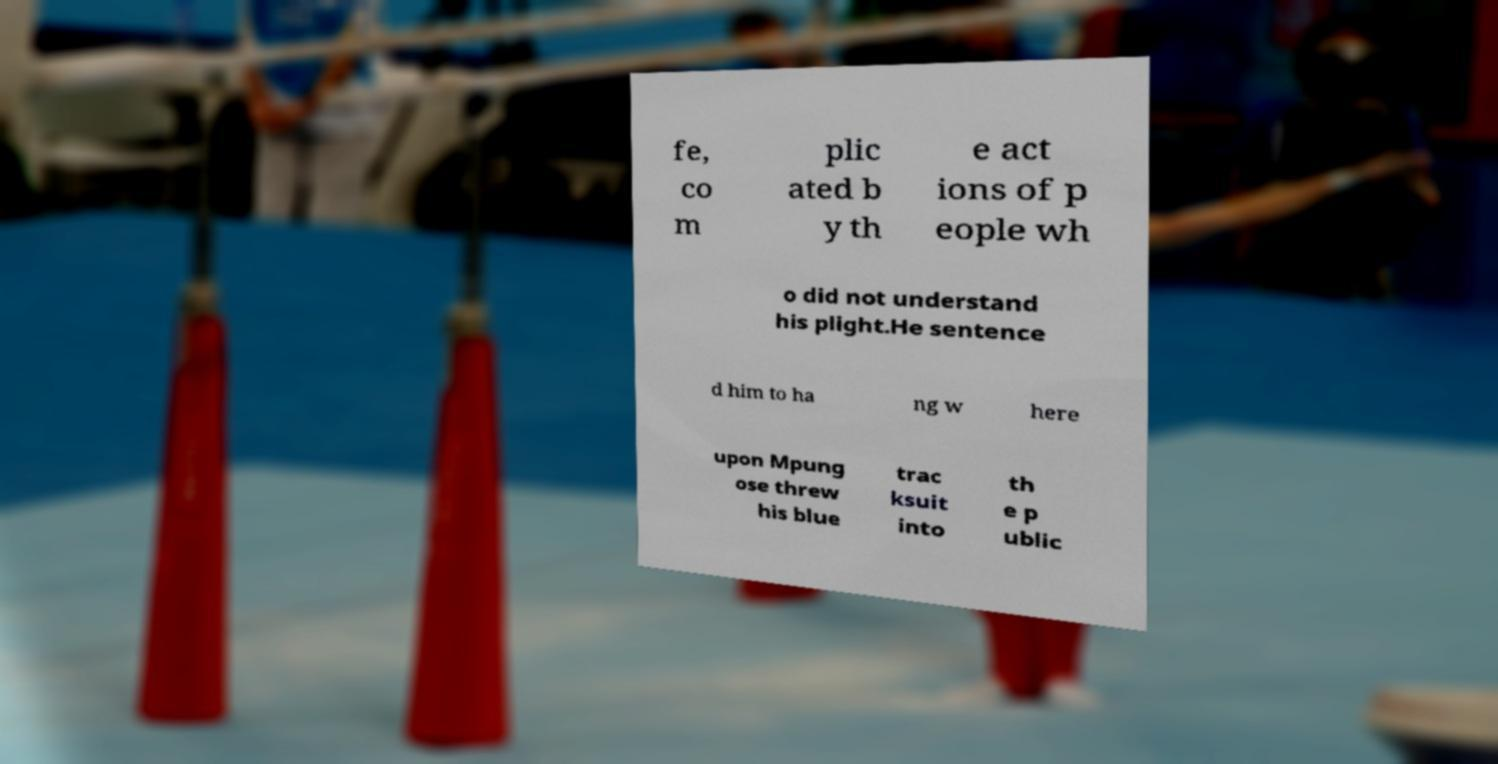For documentation purposes, I need the text within this image transcribed. Could you provide that? fe, co m plic ated b y th e act ions of p eople wh o did not understand his plight.He sentence d him to ha ng w here upon Mpung ose threw his blue trac ksuit into th e p ublic 